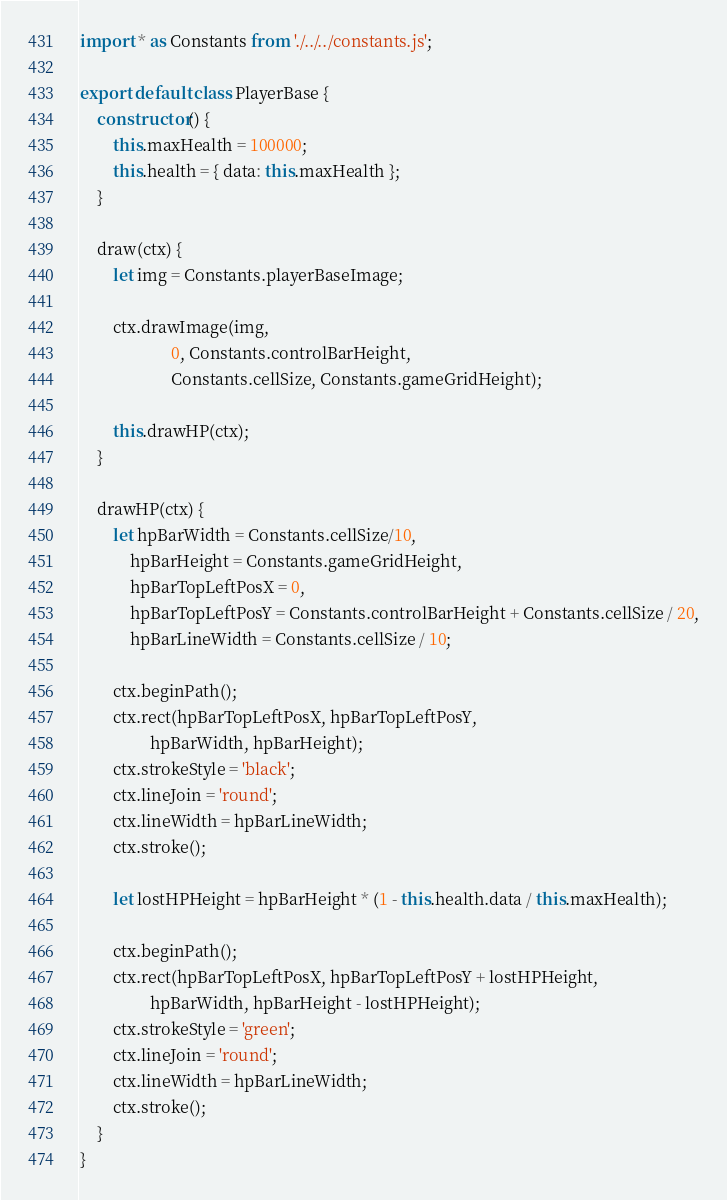Convert code to text. <code><loc_0><loc_0><loc_500><loc_500><_JavaScript_>import * as Constants from './../../constants.js';

export default class PlayerBase {
    constructor() {
        this.maxHealth = 100000;
        this.health = { data: this.maxHealth };
    }

    draw(ctx) {
        let img = Constants.playerBaseImage;

        ctx.drawImage(img,
                      0, Constants.controlBarHeight,
                      Constants.cellSize, Constants.gameGridHeight);

        this.drawHP(ctx);
    }

    drawHP(ctx) {
        let hpBarWidth = Constants.cellSize/10,
            hpBarHeight = Constants.gameGridHeight,
            hpBarTopLeftPosX = 0,
            hpBarTopLeftPosY = Constants.controlBarHeight + Constants.cellSize / 20,
            hpBarLineWidth = Constants.cellSize / 10;

        ctx.beginPath();
        ctx.rect(hpBarTopLeftPosX, hpBarTopLeftPosY,
                 hpBarWidth, hpBarHeight);
        ctx.strokeStyle = 'black';
        ctx.lineJoin = 'round';
        ctx.lineWidth = hpBarLineWidth;
        ctx.stroke();

        let lostHPHeight = hpBarHeight * (1 - this.health.data / this.maxHealth);

        ctx.beginPath();
        ctx.rect(hpBarTopLeftPosX, hpBarTopLeftPosY + lostHPHeight,
                 hpBarWidth, hpBarHeight - lostHPHeight);
        ctx.strokeStyle = 'green';
        ctx.lineJoin = 'round';
        ctx.lineWidth = hpBarLineWidth;
        ctx.stroke();
    }
}
</code> 